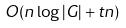Convert formula to latex. <formula><loc_0><loc_0><loc_500><loc_500>O ( n \log | G | + t n )</formula> 